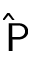<formula> <loc_0><loc_0><loc_500><loc_500>\widehat { P }</formula> 